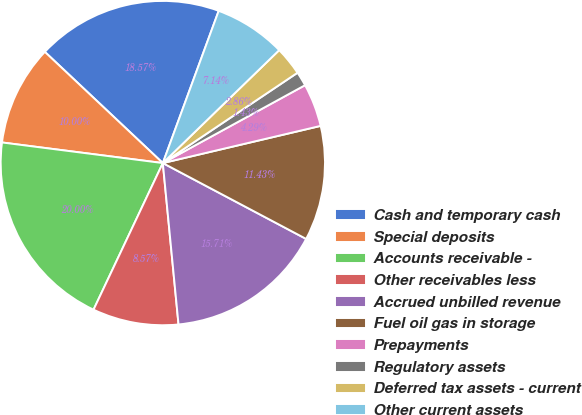Convert chart. <chart><loc_0><loc_0><loc_500><loc_500><pie_chart><fcel>Cash and temporary cash<fcel>Special deposits<fcel>Accounts receivable -<fcel>Other receivables less<fcel>Accrued unbilled revenue<fcel>Fuel oil gas in storage<fcel>Prepayments<fcel>Regulatory assets<fcel>Deferred tax assets - current<fcel>Other current assets<nl><fcel>18.57%<fcel>10.0%<fcel>20.0%<fcel>8.57%<fcel>15.71%<fcel>11.43%<fcel>4.29%<fcel>1.43%<fcel>2.86%<fcel>7.14%<nl></chart> 